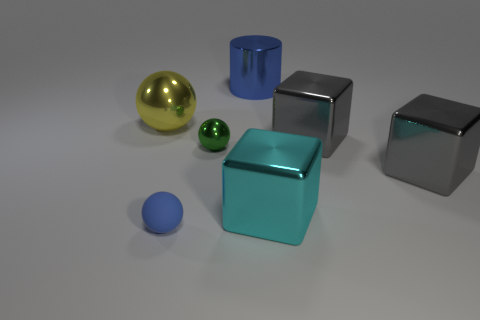Is there anything else that has the same shape as the large blue object?
Make the answer very short. No. Do the green metal thing and the cyan thing have the same shape?
Your answer should be very brief. No. Is there anything else that has the same material as the small blue sphere?
Your answer should be very brief. No. How big is the green sphere?
Offer a very short reply. Small. There is a object that is both behind the green shiny thing and on the left side of the small green thing; what color is it?
Your answer should be very brief. Yellow. Are there more cyan metal cubes than big green shiny spheres?
Give a very brief answer. Yes. What number of things are yellow things or metallic objects behind the big cyan cube?
Offer a terse response. 5. Do the shiny cylinder and the cyan metal cube have the same size?
Your answer should be very brief. Yes. Are there any shiny spheres in front of the metal cylinder?
Your answer should be very brief. Yes. What is the size of the thing that is left of the cyan metal object and to the right of the tiny green metal object?
Your answer should be compact. Large. 